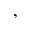Convert formula to latex. <formula><loc_0><loc_0><loc_500><loc_500>,</formula> 